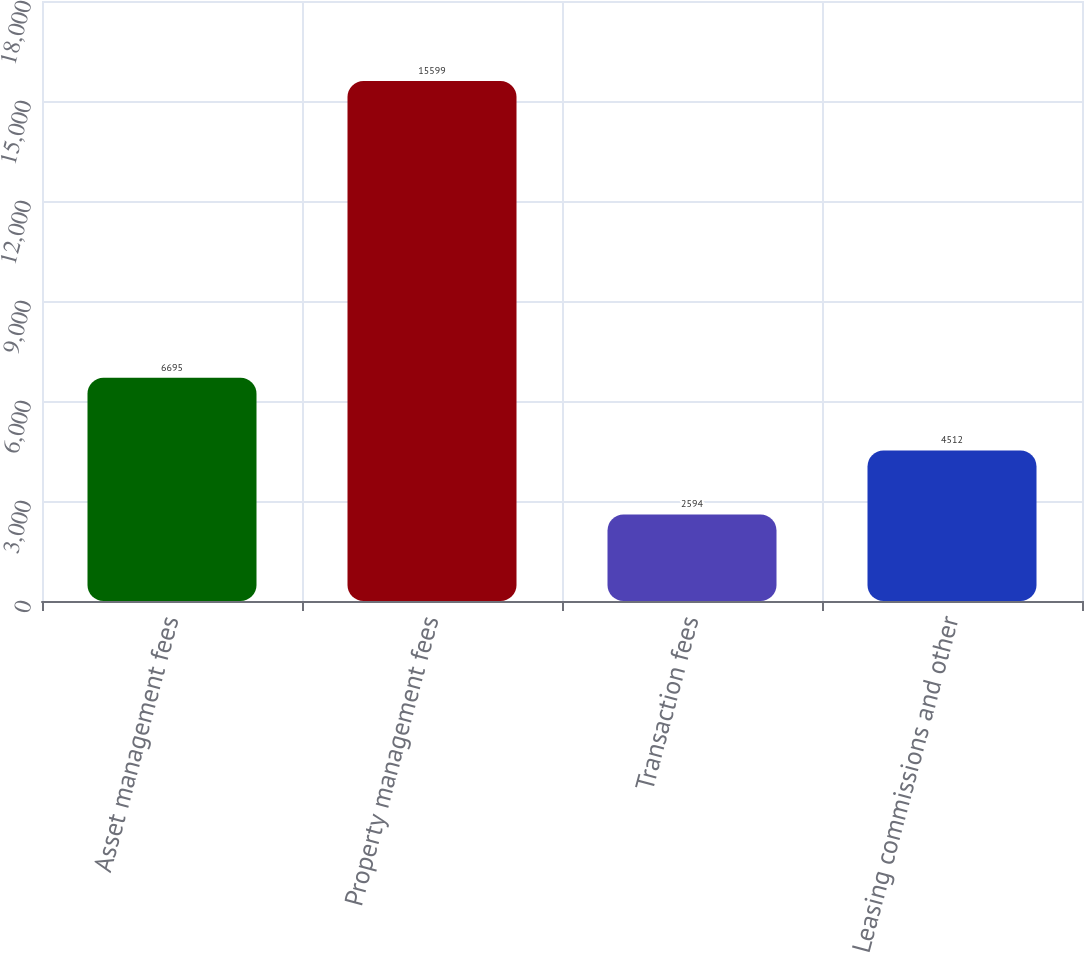<chart> <loc_0><loc_0><loc_500><loc_500><bar_chart><fcel>Asset management fees<fcel>Property management fees<fcel>Transaction fees<fcel>Leasing commissions and other<nl><fcel>6695<fcel>15599<fcel>2594<fcel>4512<nl></chart> 